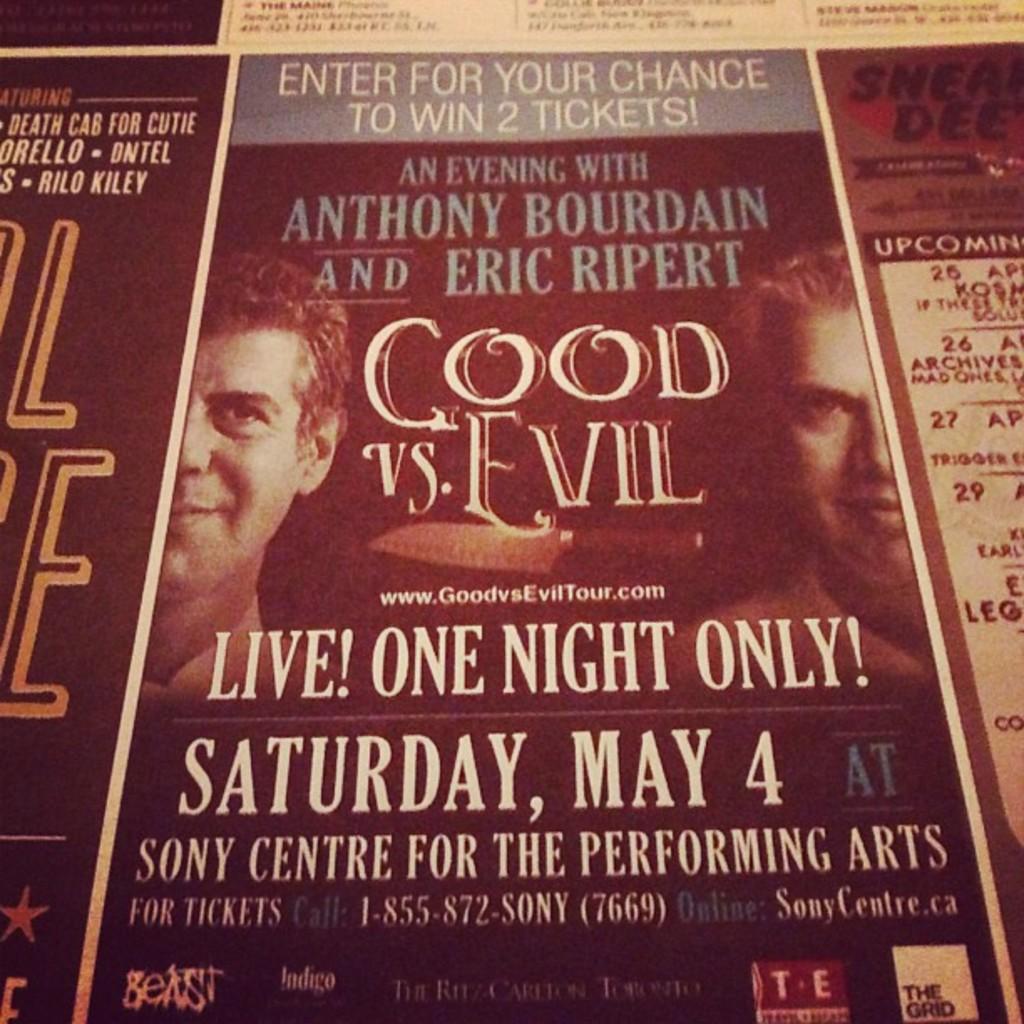What month is this event?
Provide a succinct answer. May. Who is this an evening with?
Provide a succinct answer. Anthony bourdain and eric ripert. 